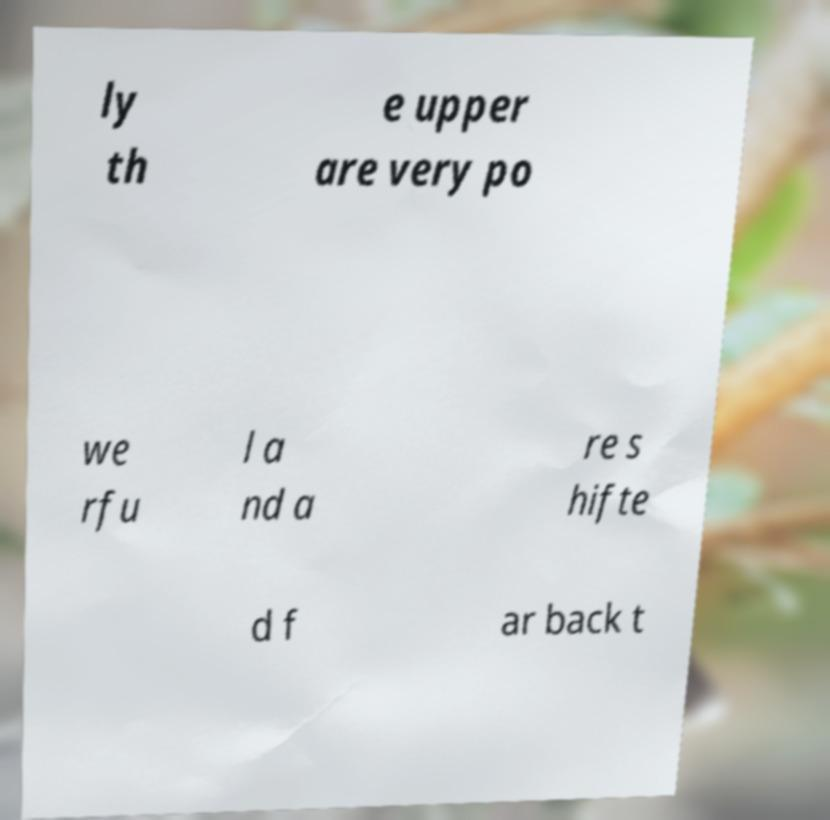Please identify and transcribe the text found in this image. ly th e upper are very po we rfu l a nd a re s hifte d f ar back t 